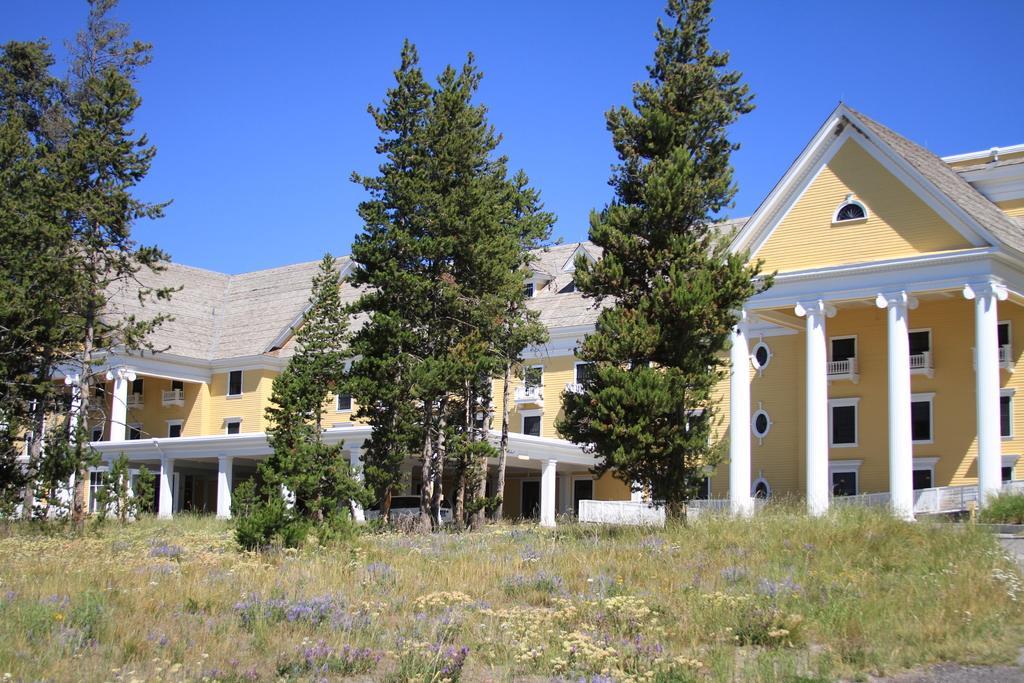Please provide a concise description of this image. In this picture there is a building and there are trees. In the foreground there is a vehicle and there is a railing. At the top there is sky. At the bottom there are flowers and plants and there is grass and there is a pavement. 